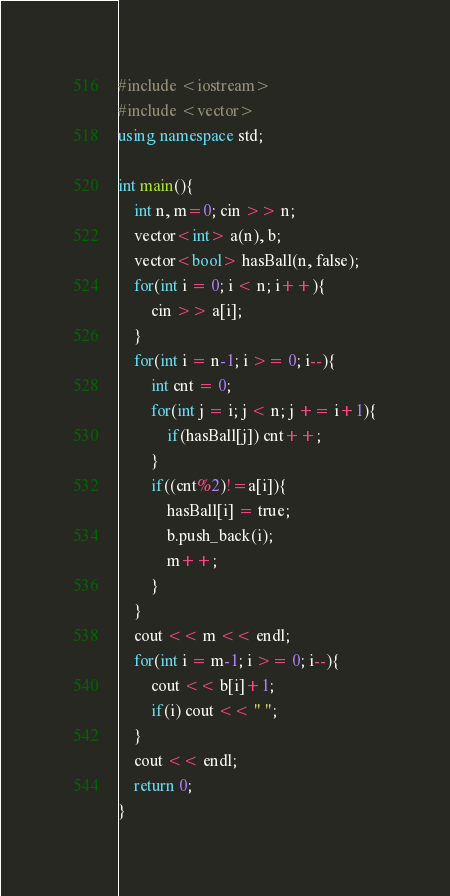Convert code to text. <code><loc_0><loc_0><loc_500><loc_500><_C++_>#include <iostream>
#include <vector>
using namespace std;

int main(){
    int n, m=0; cin >> n;
    vector<int> a(n), b;
    vector<bool> hasBall(n, false);
    for(int i = 0; i < n; i++){
        cin >> a[i];
    }
    for(int i = n-1; i >= 0; i--){
        int cnt = 0;
        for(int j = i; j < n; j += i+1){
            if(hasBall[j]) cnt++;
        }
        if((cnt%2)!=a[i]){
            hasBall[i] = true;
            b.push_back(i);
            m++;
        }
    }
    cout << m << endl;
    for(int i = m-1; i >= 0; i--){
        cout << b[i]+1;
        if(i) cout << " ";
    }
    cout << endl;
    return 0;
}
</code> 